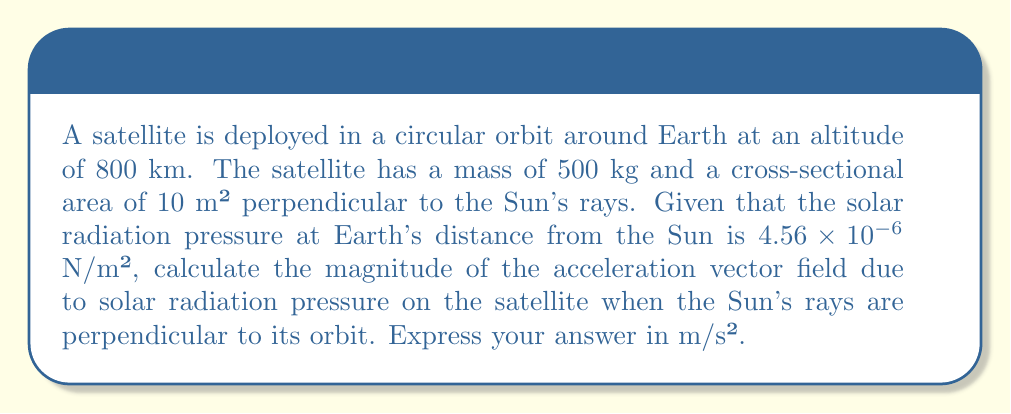Teach me how to tackle this problem. Let's approach this step-by-step:

1) The force due to solar radiation pressure is given by:

   $$F = PA$$

   where $P$ is the solar radiation pressure and $A$ is the cross-sectional area.

2) Given:
   $P = 4.56 \times 10^{-6}$ N/m²
   $A = 10$ m²

3) Calculate the force:

   $$F = (4.56 \times 10^{-6} \text{ N/m²}) \times (10 \text{ m²}) = 4.56 \times 10^{-5} \text{ N}$$

4) Now, we can use Newton's Second Law to find the acceleration:

   $$a = \frac{F}{m}$$

   where $m$ is the mass of the satellite.

5) Given:
   $m = 500$ kg

6) Calculate the acceleration:

   $$a = \frac{4.56 \times 10^{-5} \text{ N}}{500 \text{ kg}} = 9.12 \times 10^{-8} \text{ m/s²}$$

7) This acceleration forms a vector field around the Earth, always pointing away from the Sun. The magnitude of this vector field is constant for a given distance from the Sun, which is what we've calculated.
Answer: $9.12 \times 10^{-8}$ m/s² 